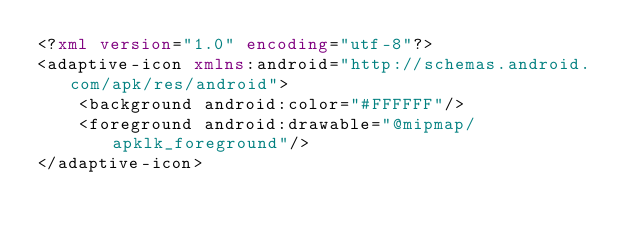Convert code to text. <code><loc_0><loc_0><loc_500><loc_500><_XML_><?xml version="1.0" encoding="utf-8"?>
<adaptive-icon xmlns:android="http://schemas.android.com/apk/res/android">
    <background android:color="#FFFFFF"/>
    <foreground android:drawable="@mipmap/apklk_foreground"/>
</adaptive-icon></code> 